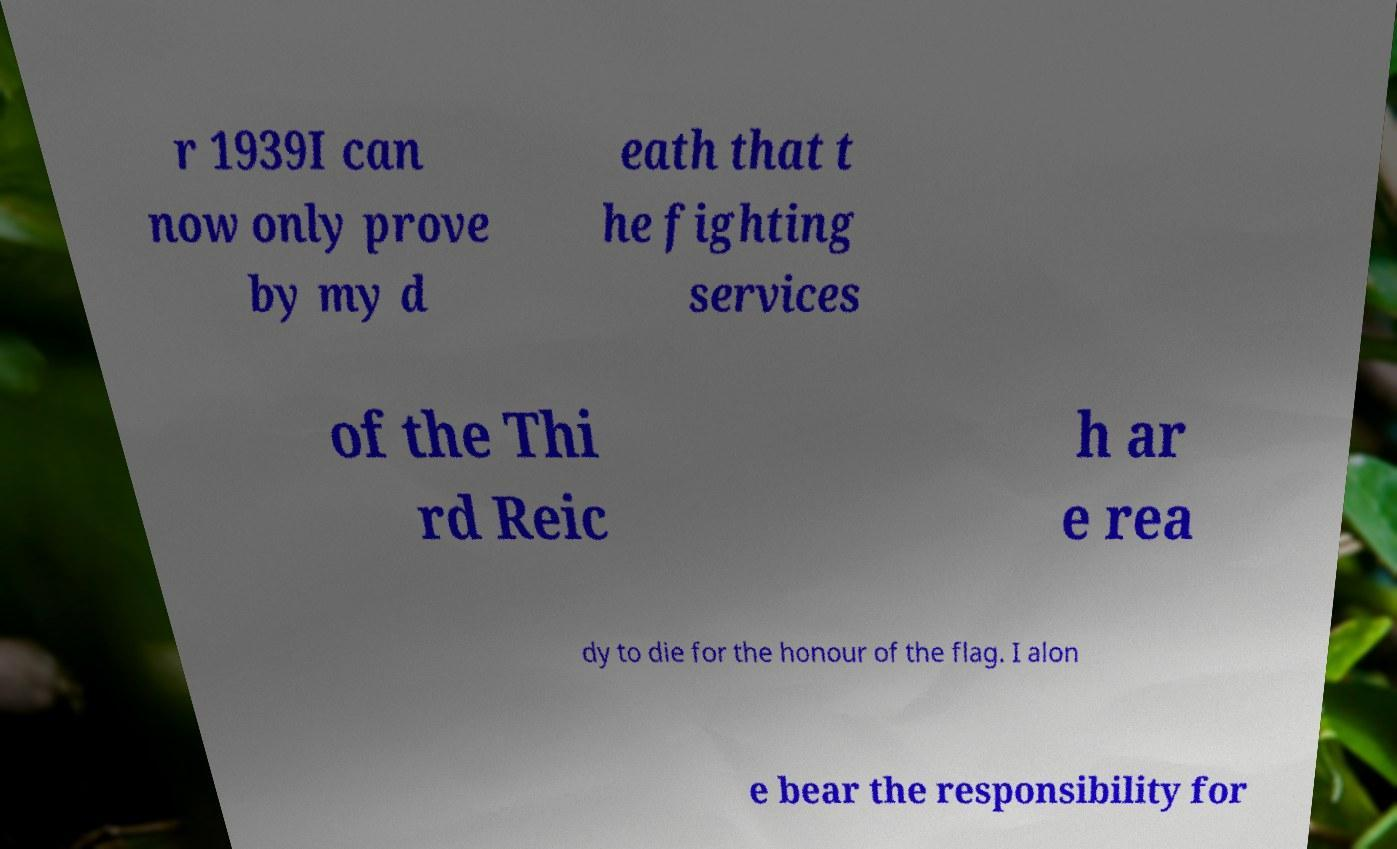Could you extract and type out the text from this image? r 1939I can now only prove by my d eath that t he fighting services of the Thi rd Reic h ar e rea dy to die for the honour of the flag. I alon e bear the responsibility for 